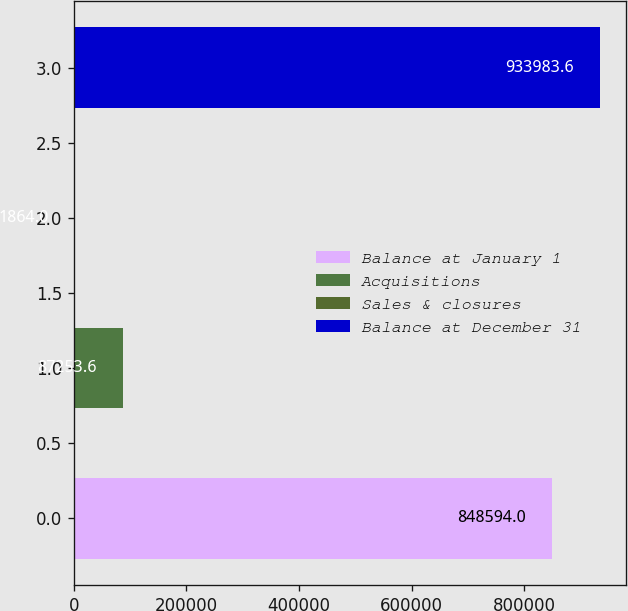Convert chart. <chart><loc_0><loc_0><loc_500><loc_500><bar_chart><fcel>Balance at January 1<fcel>Acquisitions<fcel>Sales & closures<fcel>Balance at December 31<nl><fcel>848594<fcel>87253.6<fcel>1864<fcel>933984<nl></chart> 